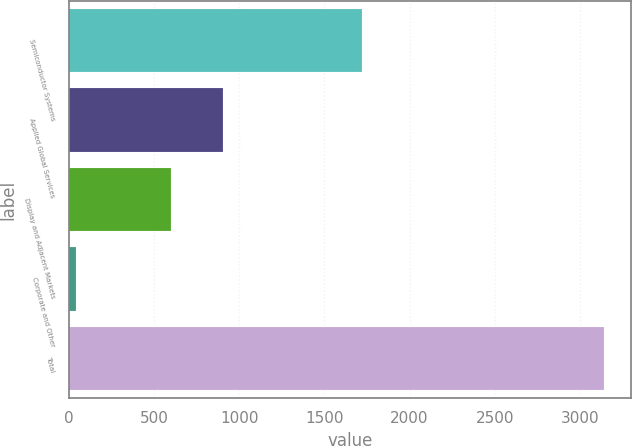Convert chart to OTSL. <chart><loc_0><loc_0><loc_500><loc_500><bar_chart><fcel>Semiconductor Systems<fcel>Applied Global Services<fcel>Display and Adjacent Markets<fcel>Corporate and Other<fcel>Total<nl><fcel>1720<fcel>907.7<fcel>598<fcel>45<fcel>3142<nl></chart> 